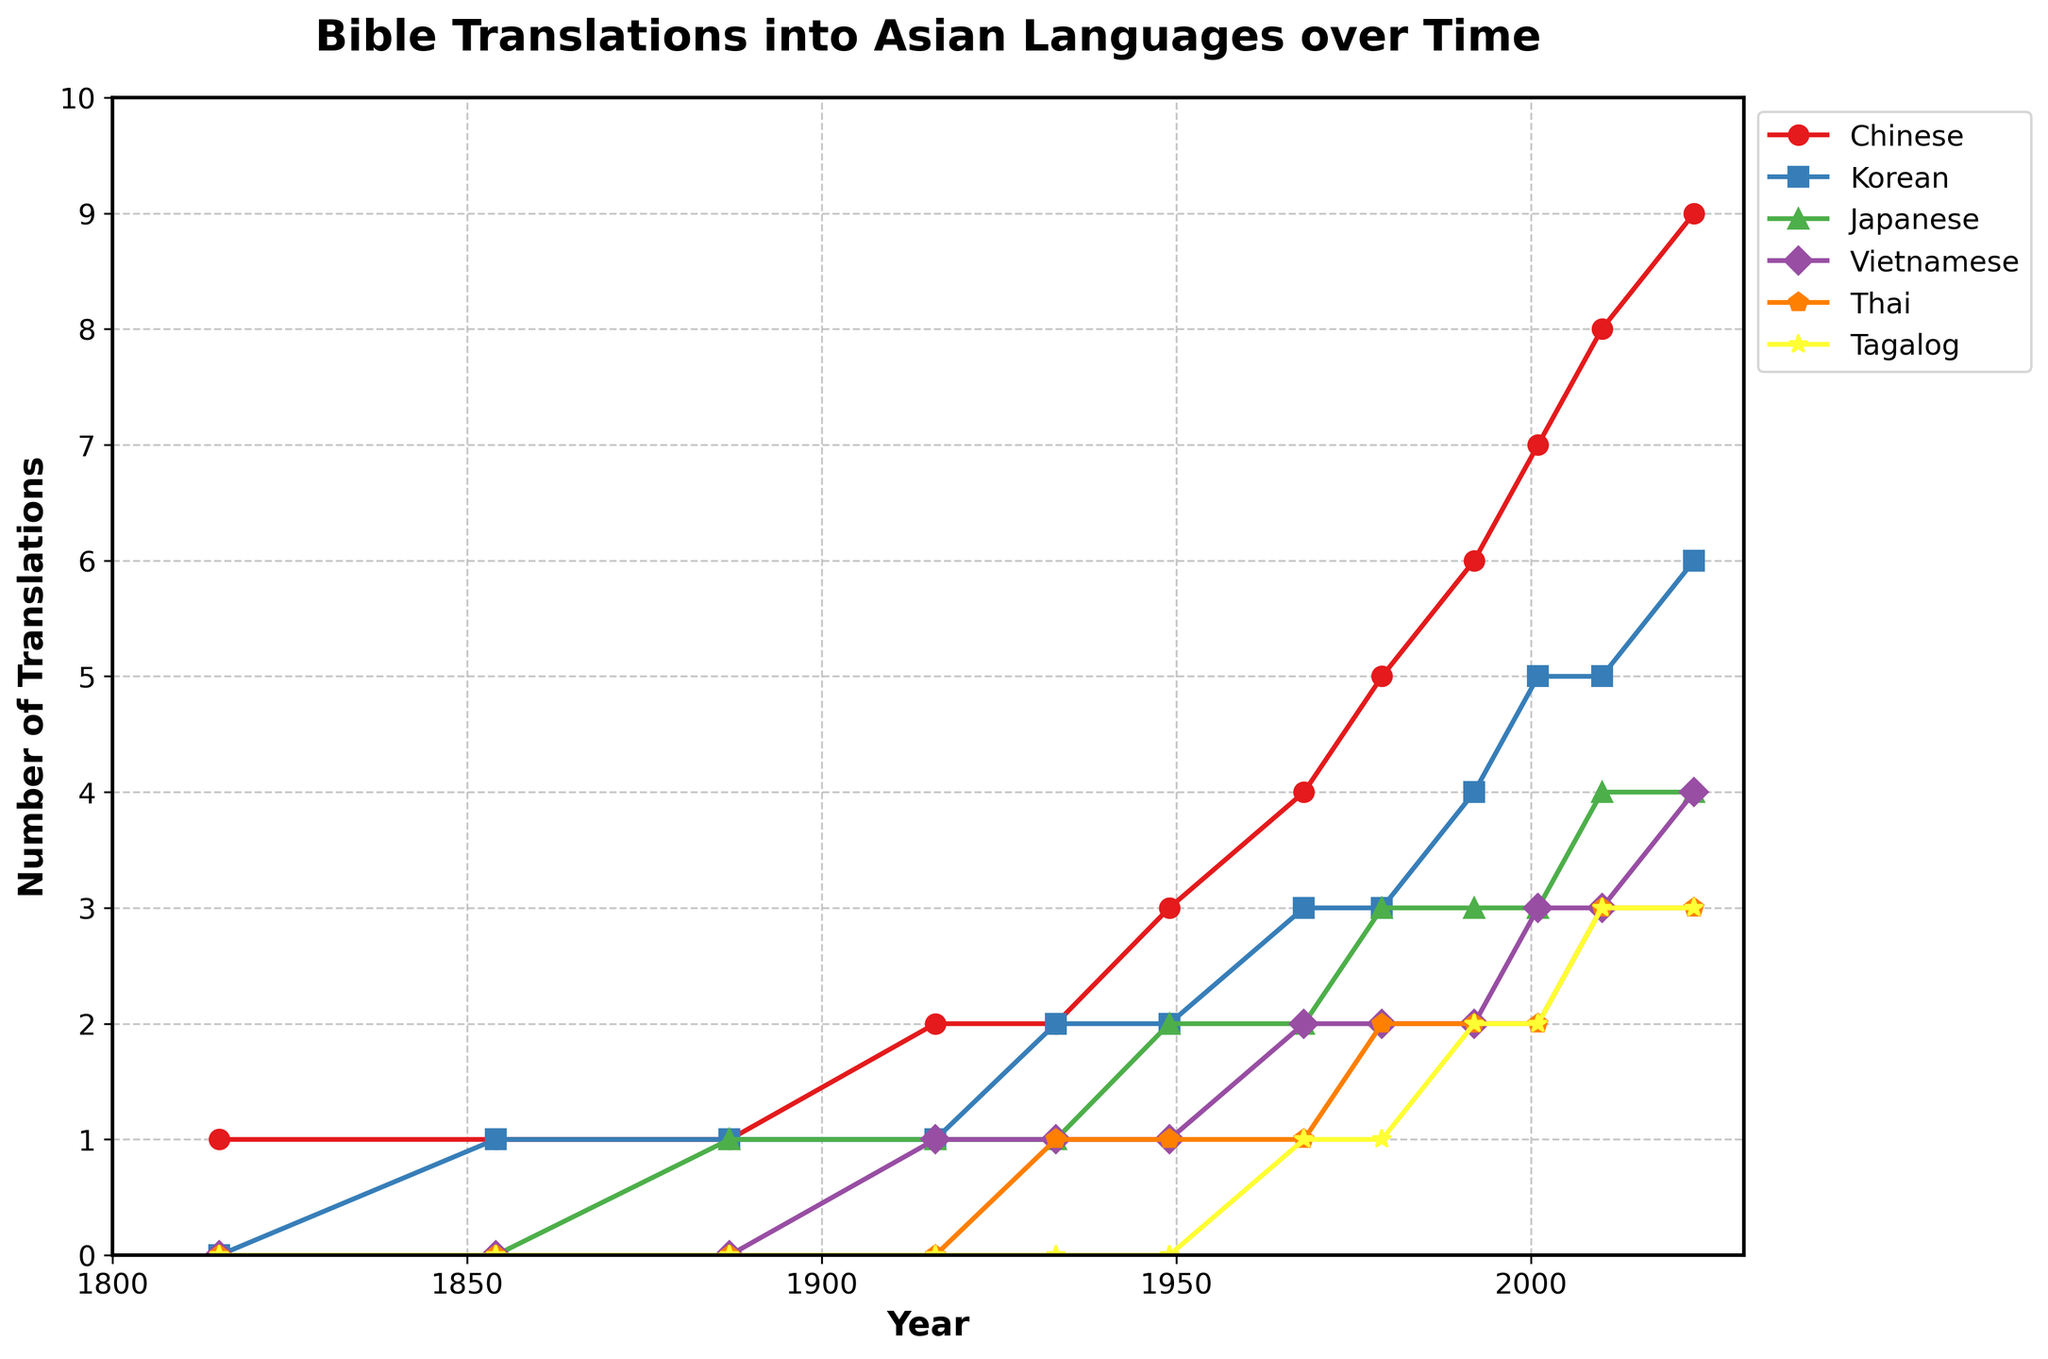Which language has the most translations by year 2023? Observe the chart and note that the line representing Chinese reaches the highest y-value (9) in 2023, compared to other languages.
Answer: Chinese In which year did Vietnamese translations first reach 1? Locate the Vietnamese line (green) and identify the point where it first crosses y=1, which is in year 1916.
Answer: 1916 How many languages had exactly 3 translations in the year 1979? Find the year 1979 on the x-axis and track vertically. Note that two lines (Korean and Thai) intersect y=3.
Answer: 2 Between which years did the number of Tagalog translations increase from 1 to 3? Identify the points on the pink-colored Tagalog line for y=1 and y=3, which occur between the years 1968 and 2010.
Answer: 1968-2010 Which language had no translations by 1916? Examine the year 1916 and identify any lines that haven't reached at least y=1 by then. Thai and Tagalog are both at 0.
Answer: Thai and Tagalog Compare the number of Japanese translations in 1949 and in 2023. How much did it increase? Note the y-values for Japanese in 1949 (2) and in 2023 (4). The increase is 4 - 2 = 2.
Answer: 2 What was the overall trend of Bible translations into Korean from 1854 to 2023? Observe the blue line representing Korean translations. Notice that it starts at 1 in 1854 and increases gradually to 6 by 2023.
Answer: Increasing trend How many years after the first Chinese translation did the first Korean translation occur? The first Chinese translation occurs in 1815 and the first Korean in 1854. Calculate the difference: 1854 - 1815 = 39 years.
Answer: 39 years Between which years did the number of Chinese translations remain unchanged at 2? Find the period where the red line remains flat at y=2, which is between 1916 and 1933.
Answer: 1916-1933 In which decade did the number of Thai translations first reach 1? Locate the point where the yellow Thai line first reaches y=1, which is in the 1930s.
Answer: 1930s 